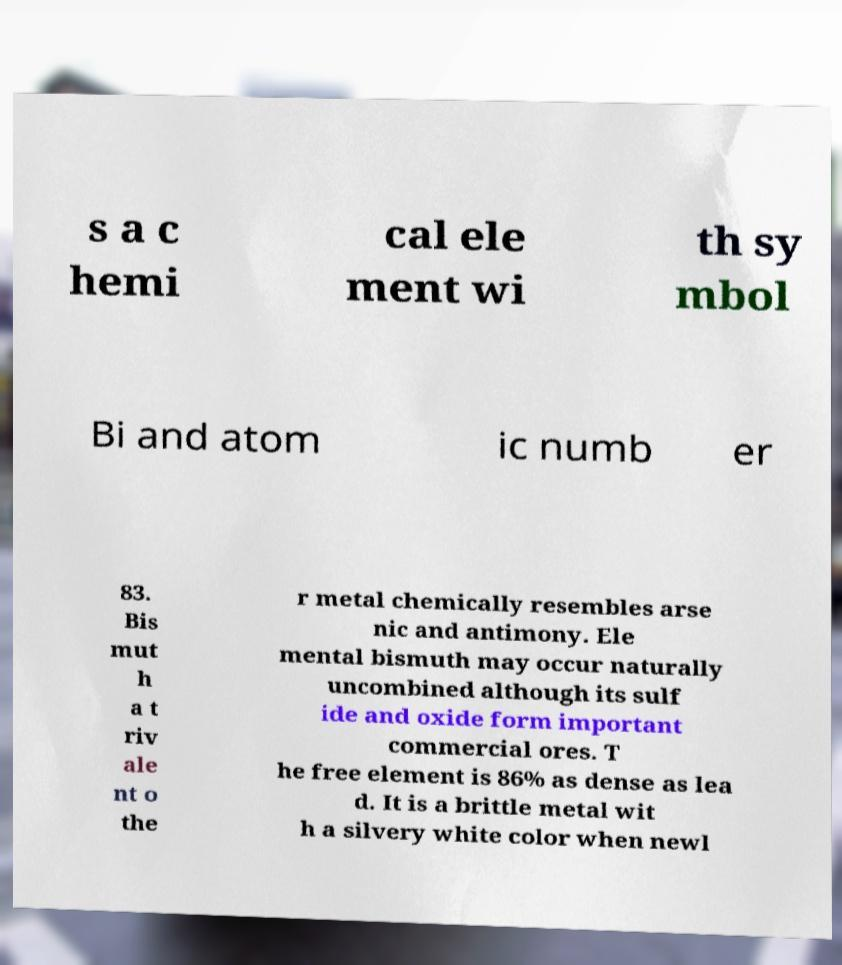Please read and relay the text visible in this image. What does it say? s a c hemi cal ele ment wi th sy mbol Bi and atom ic numb er 83. Bis mut h a t riv ale nt o the r metal chemically resembles arse nic and antimony. Ele mental bismuth may occur naturally uncombined although its sulf ide and oxide form important commercial ores. T he free element is 86% as dense as lea d. It is a brittle metal wit h a silvery white color when newl 